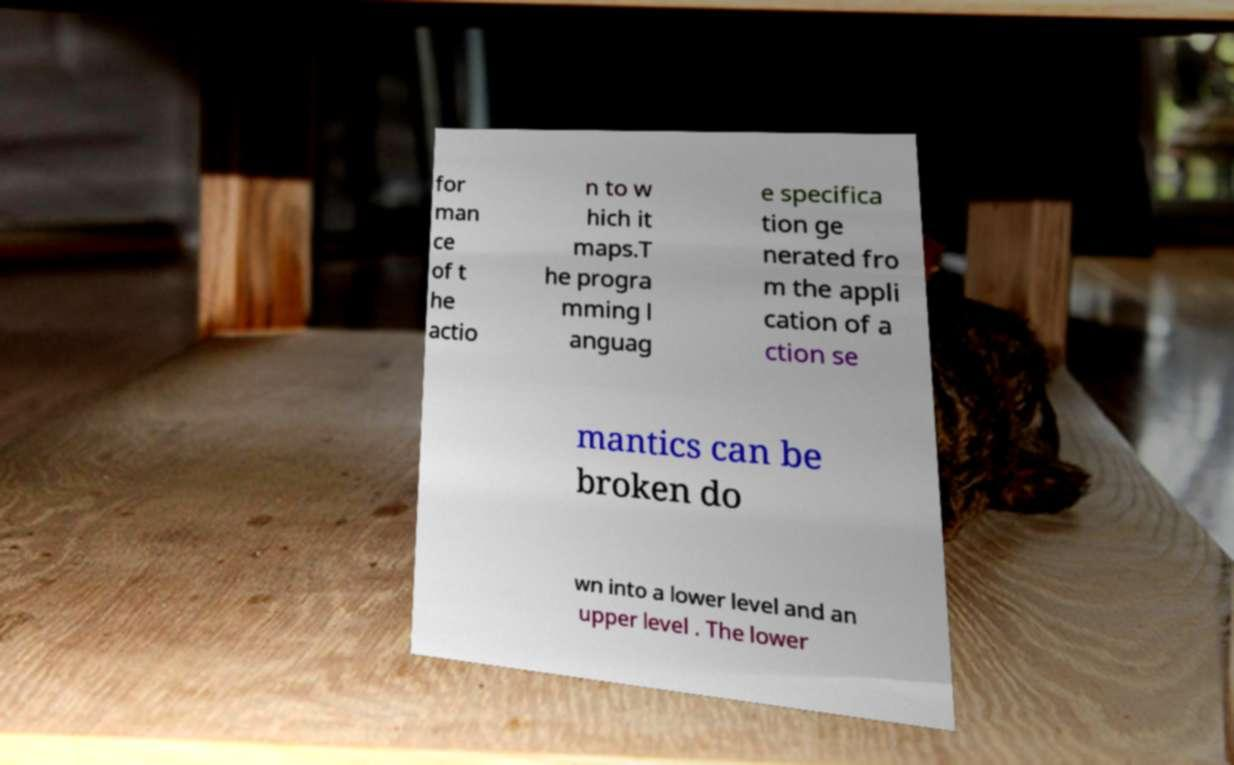What messages or text are displayed in this image? I need them in a readable, typed format. for man ce of t he actio n to w hich it maps.T he progra mming l anguag e specifica tion ge nerated fro m the appli cation of a ction se mantics can be broken do wn into a lower level and an upper level . The lower 